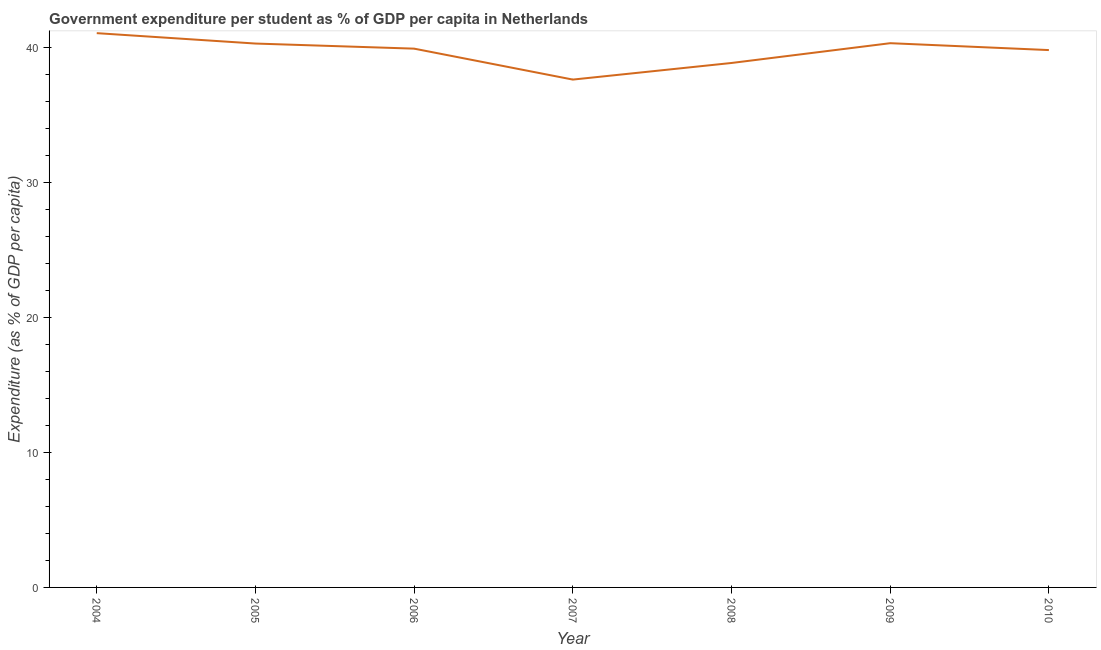What is the government expenditure per student in 2007?
Provide a succinct answer. 37.6. Across all years, what is the maximum government expenditure per student?
Ensure brevity in your answer.  41.03. Across all years, what is the minimum government expenditure per student?
Your answer should be very brief. 37.6. In which year was the government expenditure per student minimum?
Ensure brevity in your answer.  2007. What is the sum of the government expenditure per student?
Provide a short and direct response. 277.67. What is the difference between the government expenditure per student in 2005 and 2010?
Ensure brevity in your answer.  0.48. What is the average government expenditure per student per year?
Provide a short and direct response. 39.67. What is the median government expenditure per student?
Make the answer very short. 39.89. In how many years, is the government expenditure per student greater than 12 %?
Keep it short and to the point. 7. What is the ratio of the government expenditure per student in 2004 to that in 2010?
Ensure brevity in your answer.  1.03. What is the difference between the highest and the second highest government expenditure per student?
Your response must be concise. 0.74. What is the difference between the highest and the lowest government expenditure per student?
Offer a very short reply. 3.44. In how many years, is the government expenditure per student greater than the average government expenditure per student taken over all years?
Your response must be concise. 5. How many lines are there?
Provide a short and direct response. 1. What is the difference between two consecutive major ticks on the Y-axis?
Your answer should be very brief. 10. Are the values on the major ticks of Y-axis written in scientific E-notation?
Ensure brevity in your answer.  No. Does the graph contain any zero values?
Give a very brief answer. No. Does the graph contain grids?
Offer a very short reply. No. What is the title of the graph?
Provide a short and direct response. Government expenditure per student as % of GDP per capita in Netherlands. What is the label or title of the Y-axis?
Keep it short and to the point. Expenditure (as % of GDP per capita). What is the Expenditure (as % of GDP per capita) in 2004?
Offer a terse response. 41.03. What is the Expenditure (as % of GDP per capita) in 2005?
Your answer should be compact. 40.26. What is the Expenditure (as % of GDP per capita) in 2006?
Keep it short and to the point. 39.89. What is the Expenditure (as % of GDP per capita) in 2007?
Offer a terse response. 37.6. What is the Expenditure (as % of GDP per capita) in 2008?
Make the answer very short. 38.82. What is the Expenditure (as % of GDP per capita) of 2009?
Provide a short and direct response. 40.29. What is the Expenditure (as % of GDP per capita) in 2010?
Give a very brief answer. 39.78. What is the difference between the Expenditure (as % of GDP per capita) in 2004 and 2005?
Your answer should be very brief. 0.77. What is the difference between the Expenditure (as % of GDP per capita) in 2004 and 2006?
Provide a succinct answer. 1.15. What is the difference between the Expenditure (as % of GDP per capita) in 2004 and 2007?
Offer a very short reply. 3.44. What is the difference between the Expenditure (as % of GDP per capita) in 2004 and 2008?
Your answer should be very brief. 2.21. What is the difference between the Expenditure (as % of GDP per capita) in 2004 and 2009?
Offer a very short reply. 0.74. What is the difference between the Expenditure (as % of GDP per capita) in 2004 and 2010?
Make the answer very short. 1.25. What is the difference between the Expenditure (as % of GDP per capita) in 2005 and 2006?
Your answer should be very brief. 0.38. What is the difference between the Expenditure (as % of GDP per capita) in 2005 and 2007?
Give a very brief answer. 2.67. What is the difference between the Expenditure (as % of GDP per capita) in 2005 and 2008?
Offer a very short reply. 1.44. What is the difference between the Expenditure (as % of GDP per capita) in 2005 and 2009?
Provide a succinct answer. -0.03. What is the difference between the Expenditure (as % of GDP per capita) in 2005 and 2010?
Provide a succinct answer. 0.48. What is the difference between the Expenditure (as % of GDP per capita) in 2006 and 2007?
Offer a very short reply. 2.29. What is the difference between the Expenditure (as % of GDP per capita) in 2006 and 2008?
Provide a succinct answer. 1.06. What is the difference between the Expenditure (as % of GDP per capita) in 2006 and 2009?
Provide a succinct answer. -0.4. What is the difference between the Expenditure (as % of GDP per capita) in 2006 and 2010?
Make the answer very short. 0.11. What is the difference between the Expenditure (as % of GDP per capita) in 2007 and 2008?
Make the answer very short. -1.23. What is the difference between the Expenditure (as % of GDP per capita) in 2007 and 2009?
Offer a terse response. -2.69. What is the difference between the Expenditure (as % of GDP per capita) in 2007 and 2010?
Ensure brevity in your answer.  -2.18. What is the difference between the Expenditure (as % of GDP per capita) in 2008 and 2009?
Offer a very short reply. -1.46. What is the difference between the Expenditure (as % of GDP per capita) in 2008 and 2010?
Your response must be concise. -0.95. What is the difference between the Expenditure (as % of GDP per capita) in 2009 and 2010?
Make the answer very short. 0.51. What is the ratio of the Expenditure (as % of GDP per capita) in 2004 to that in 2006?
Your response must be concise. 1.03. What is the ratio of the Expenditure (as % of GDP per capita) in 2004 to that in 2007?
Provide a short and direct response. 1.09. What is the ratio of the Expenditure (as % of GDP per capita) in 2004 to that in 2008?
Provide a succinct answer. 1.06. What is the ratio of the Expenditure (as % of GDP per capita) in 2004 to that in 2009?
Offer a very short reply. 1.02. What is the ratio of the Expenditure (as % of GDP per capita) in 2004 to that in 2010?
Offer a terse response. 1.03. What is the ratio of the Expenditure (as % of GDP per capita) in 2005 to that in 2006?
Your response must be concise. 1.01. What is the ratio of the Expenditure (as % of GDP per capita) in 2005 to that in 2007?
Keep it short and to the point. 1.07. What is the ratio of the Expenditure (as % of GDP per capita) in 2005 to that in 2008?
Provide a succinct answer. 1.04. What is the ratio of the Expenditure (as % of GDP per capita) in 2005 to that in 2009?
Ensure brevity in your answer.  1. What is the ratio of the Expenditure (as % of GDP per capita) in 2005 to that in 2010?
Your response must be concise. 1.01. What is the ratio of the Expenditure (as % of GDP per capita) in 2006 to that in 2007?
Keep it short and to the point. 1.06. What is the ratio of the Expenditure (as % of GDP per capita) in 2006 to that in 2008?
Offer a terse response. 1.03. What is the ratio of the Expenditure (as % of GDP per capita) in 2007 to that in 2008?
Your answer should be compact. 0.97. What is the ratio of the Expenditure (as % of GDP per capita) in 2007 to that in 2009?
Your response must be concise. 0.93. What is the ratio of the Expenditure (as % of GDP per capita) in 2007 to that in 2010?
Ensure brevity in your answer.  0.94. What is the ratio of the Expenditure (as % of GDP per capita) in 2008 to that in 2010?
Your answer should be compact. 0.98. 